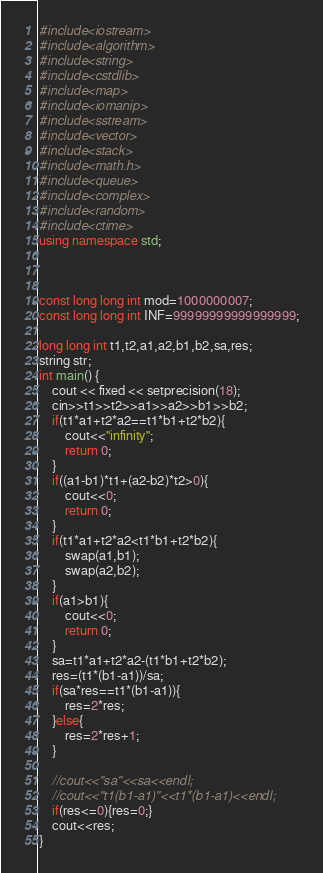Convert code to text. <code><loc_0><loc_0><loc_500><loc_500><_C++_>#include<iostream>
#include<algorithm>
#include<string>
#include<cstdlib>
#include<map>
#include<iomanip>
#include<sstream>
#include<vector>
#include<stack>
#include<math.h>
#include<queue>
#include<complex>
#include<random>
#include<ctime>
using namespace std;



const long long int mod=1000000007;
const long long int INF=99999999999999999;

long long int t1,t2,a1,a2,b1,b2,sa,res;
string str;
int main() {
	cout << fixed << setprecision(18);
	cin>>t1>>t2>>a1>>a2>>b1>>b2;
	if(t1*a1+t2*a2==t1*b1+t2*b2){
		cout<<"infinity";
		return 0;
	}
	if((a1-b1)*t1+(a2-b2)*t2>0){
		cout<<0;
		return 0;
	}
	if(t1*a1+t2*a2<t1*b1+t2*b2){
		swap(a1,b1);
		swap(a2,b2);
	}
	if(a1>b1){
		cout<<0;
		return 0;
	}
	sa=t1*a1+t2*a2-(t1*b1+t2*b2);
	res=(t1*(b1-a1))/sa;
	if(sa*res==t1*(b1-a1)){
		res=2*res;
	}else{
		res=2*res+1;
	}
	
	//cout<<"sa"<<sa<<endl;
	//cout<<"t1(b1-a1)"<<t1*(b1-a1)<<endl;
	if(res<=0){res=0;}
	cout<<res;
} 
</code> 